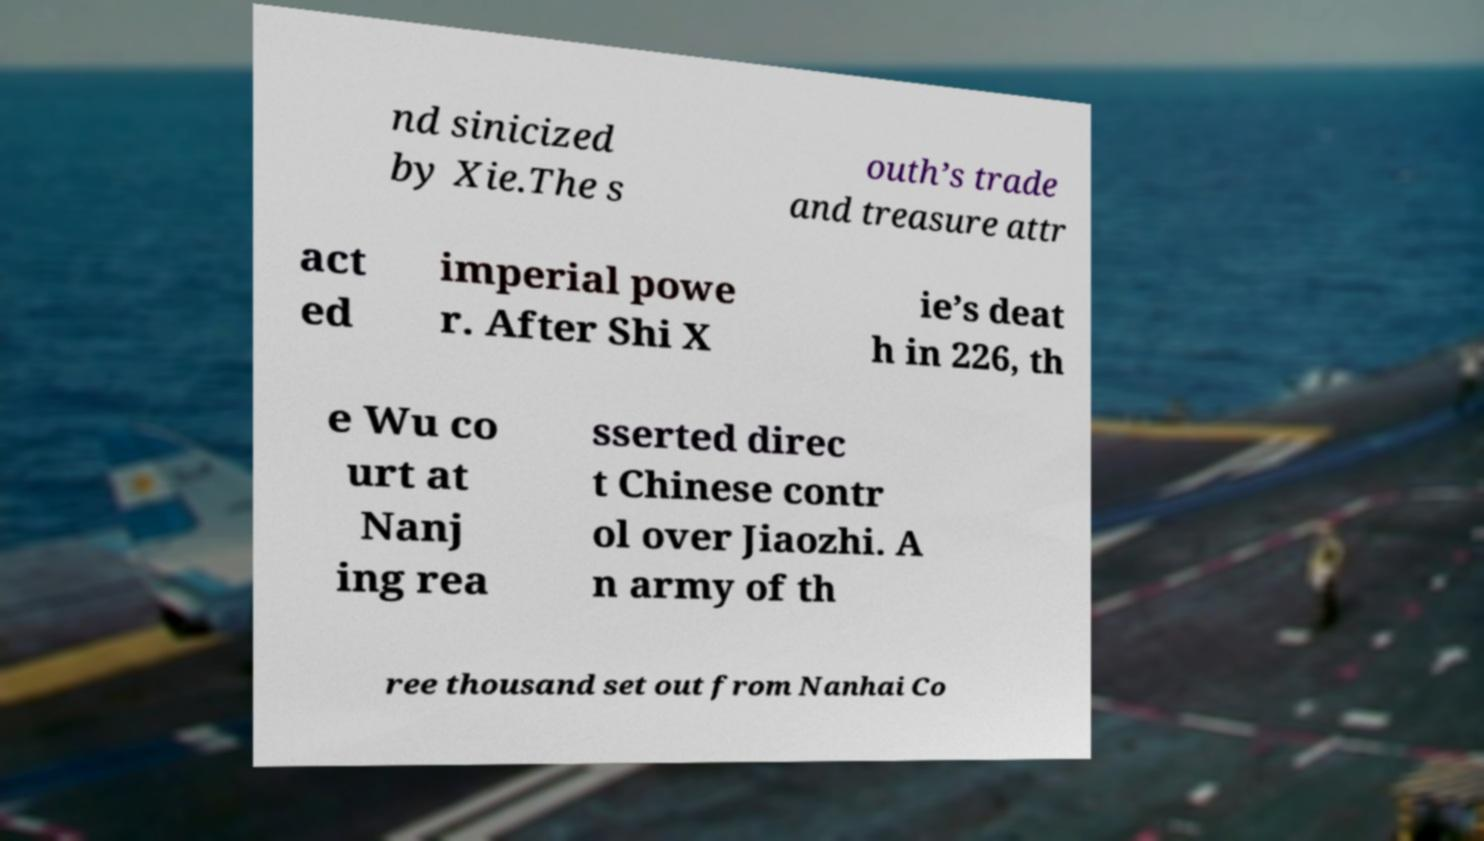I need the written content from this picture converted into text. Can you do that? nd sinicized by Xie.The s outh’s trade and treasure attr act ed imperial powe r. After Shi X ie’s deat h in 226, th e Wu co urt at Nanj ing rea sserted direc t Chinese contr ol over Jiaozhi. A n army of th ree thousand set out from Nanhai Co 